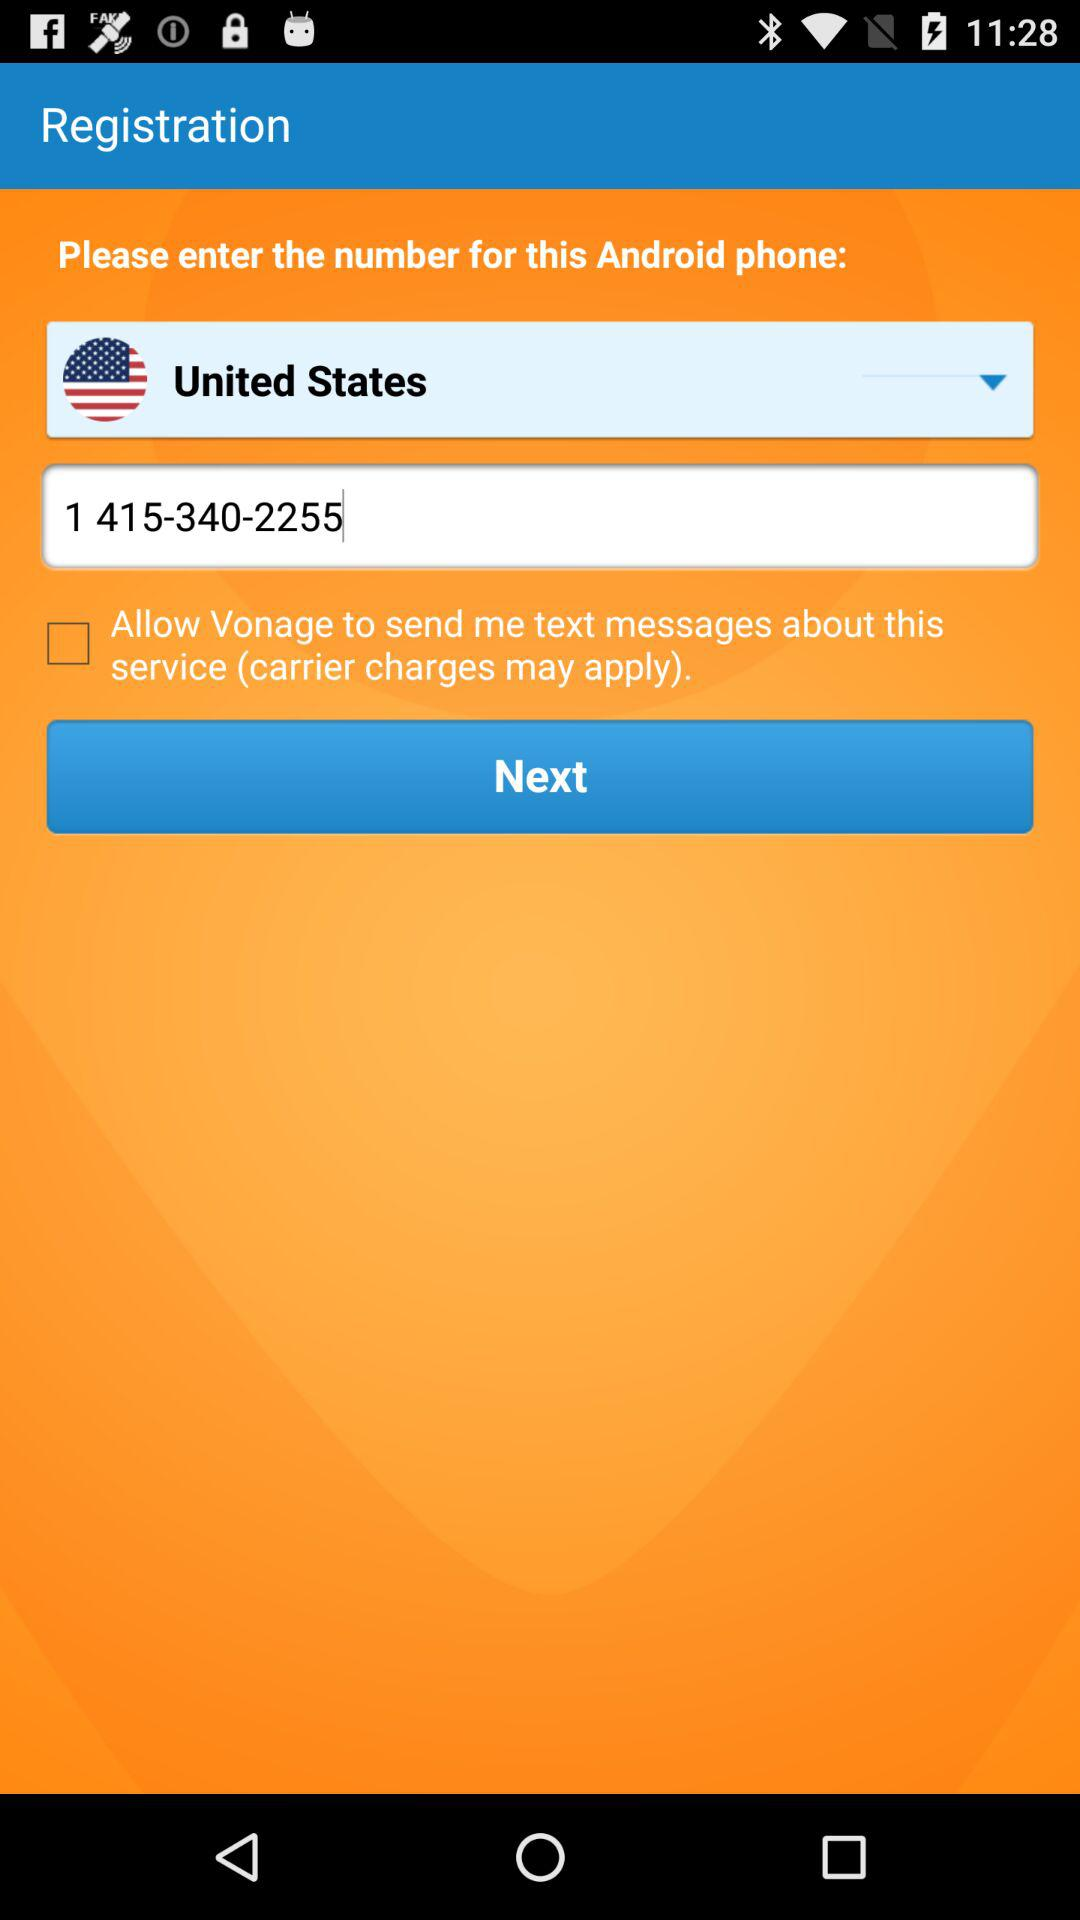What's the phone number? The phone number is 1 415-340-2255. 